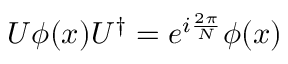Convert formula to latex. <formula><loc_0><loc_0><loc_500><loc_500>U \phi ( x ) U ^ { \dagger } = e ^ { i { \frac { 2 \pi } { N } } } \phi ( x )</formula> 